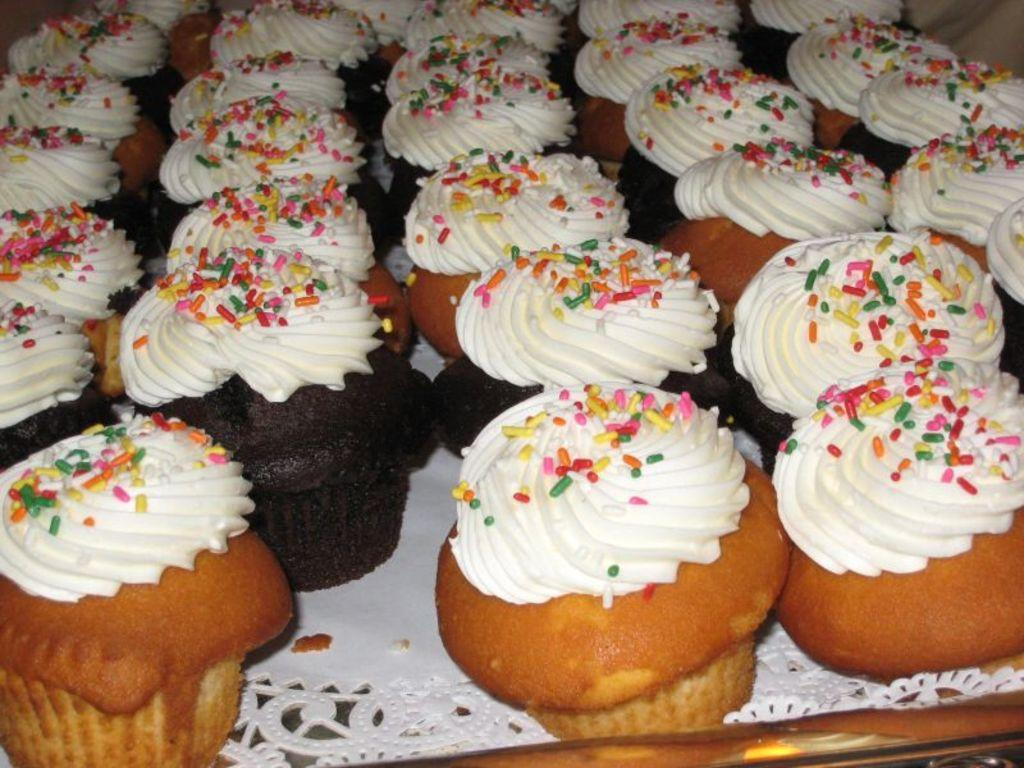What type of food can be seen in the image? There are cupcakes in the image. How are the cupcakes arranged or displayed in the image? The cupcakes are present on a tray. What type of bird is perched on the cupcakes in the image? There is no bird present in the image; it only features cupcakes on a tray. 